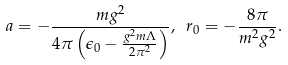<formula> <loc_0><loc_0><loc_500><loc_500>a = - \frac { m g ^ { 2 } } { 4 \pi \left ( \epsilon _ { 0 } - \frac { g ^ { 2 } m \Lambda } { 2 \pi ^ { 2 } } \right ) } , \ r _ { 0 } = - \frac { 8 \pi } { m ^ { 2 } g ^ { 2 } } .</formula> 